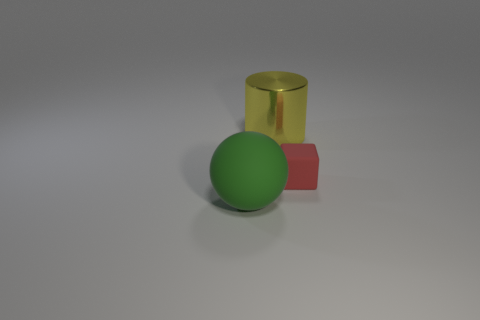The thing that is both behind the green rubber sphere and left of the small red rubber block is made of what material?
Keep it short and to the point. Metal. What number of other large rubber objects have the same shape as the big green matte object?
Make the answer very short. 0. There is a object that is in front of the tiny red object; what is its material?
Give a very brief answer. Rubber. Are there fewer large matte objects in front of the green ball than small purple matte cubes?
Offer a terse response. No. Are there any other things that are the same shape as the red thing?
Provide a succinct answer. No. Are there any big spheres?
Your answer should be very brief. Yes. There is a big object behind the rubber thing to the right of the big green object; what is it made of?
Provide a short and direct response. Metal. What color is the big cylinder?
Make the answer very short. Yellow. Are there any other large balls of the same color as the ball?
Ensure brevity in your answer.  No. What number of other tiny matte blocks are the same color as the tiny cube?
Your answer should be compact. 0. 